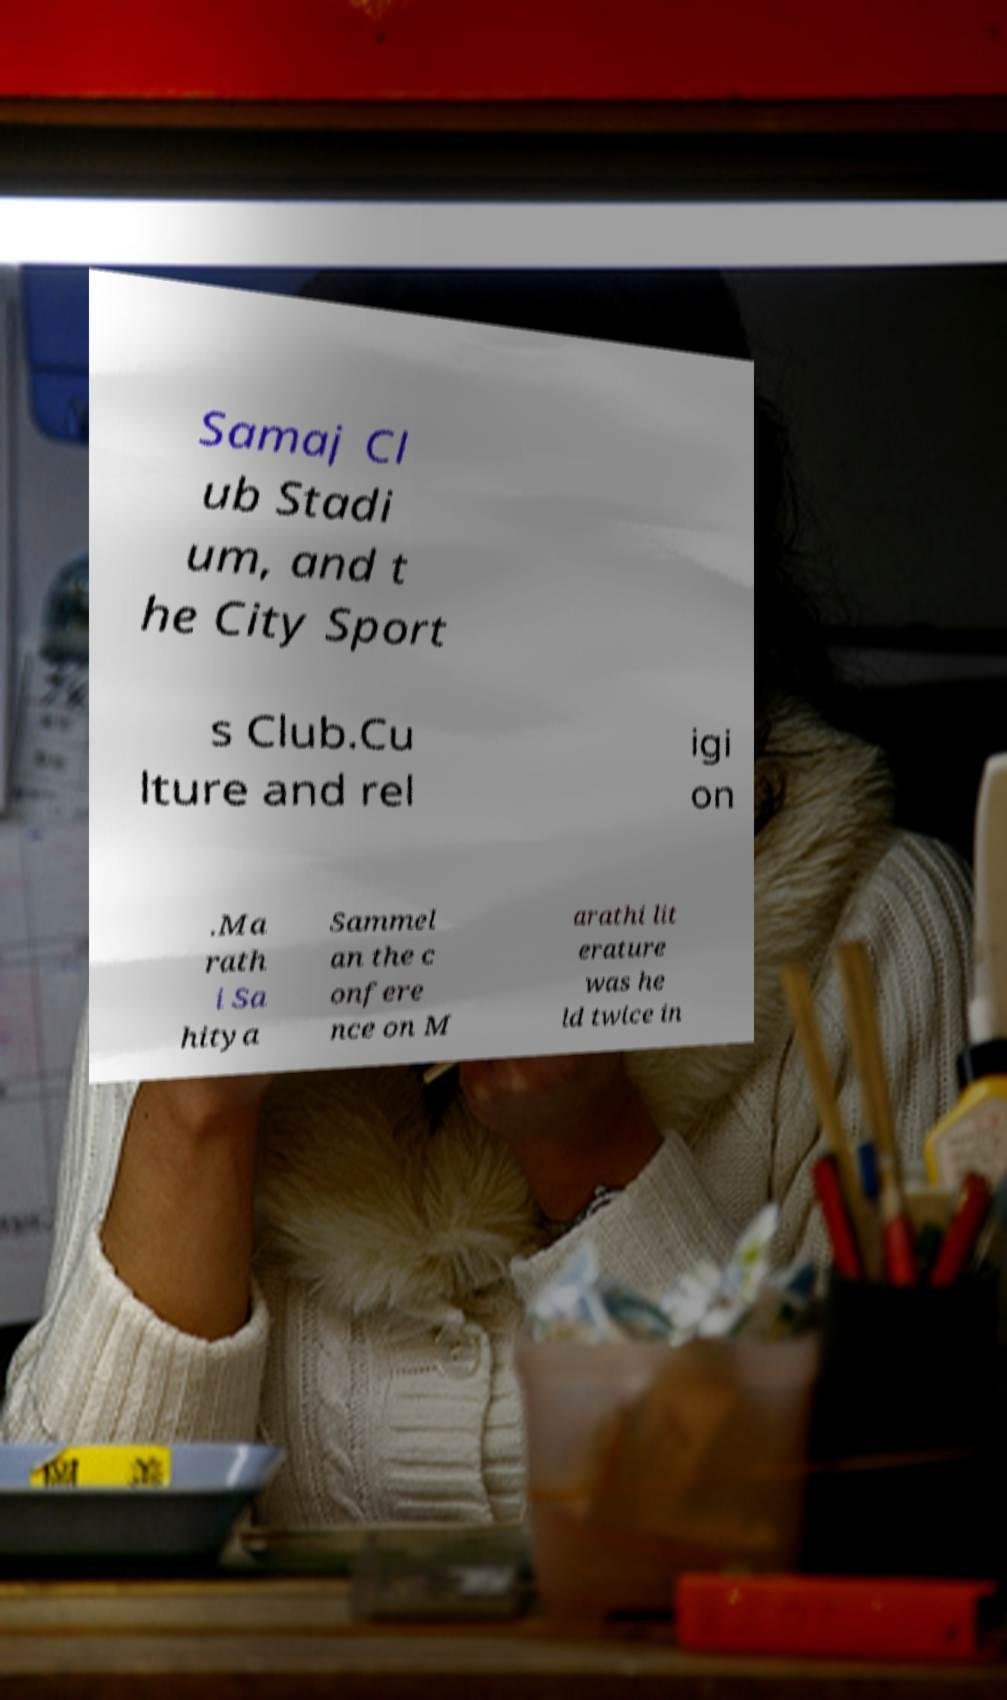There's text embedded in this image that I need extracted. Can you transcribe it verbatim? Samaj Cl ub Stadi um, and t he City Sport s Club.Cu lture and rel igi on .Ma rath i Sa hitya Sammel an the c onfere nce on M arathi lit erature was he ld twice in 